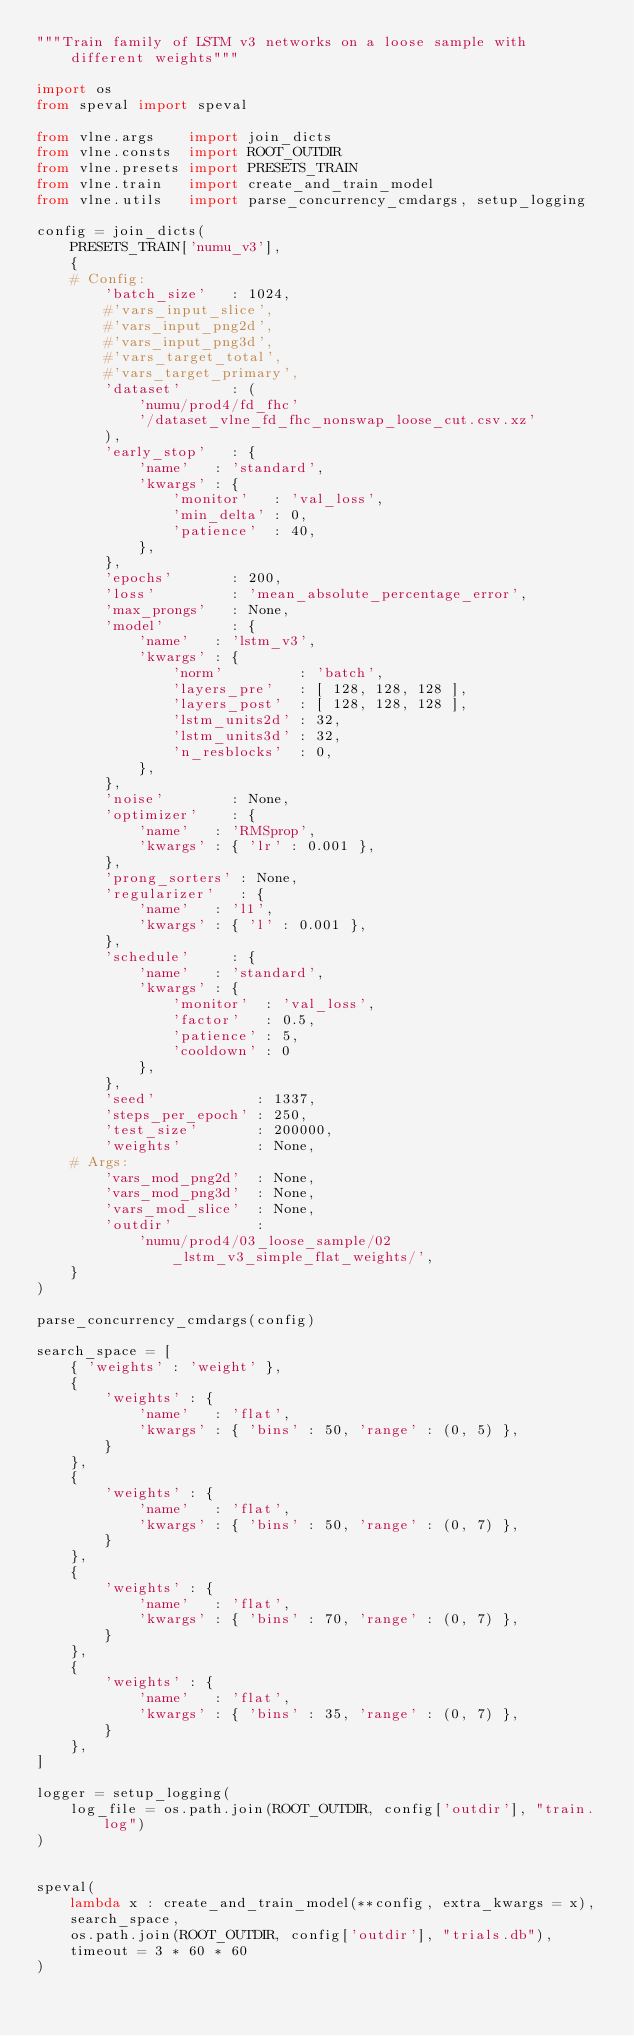Convert code to text. <code><loc_0><loc_0><loc_500><loc_500><_Python_>"""Train family of LSTM v3 networks on a loose sample with different weights"""

import os
from speval import speval

from vlne.args    import join_dicts
from vlne.consts  import ROOT_OUTDIR
from vlne.presets import PRESETS_TRAIN
from vlne.train   import create_and_train_model
from vlne.utils   import parse_concurrency_cmdargs, setup_logging

config = join_dicts(
    PRESETS_TRAIN['numu_v3'],
    {
    # Config:
        'batch_size'   : 1024,
        #'vars_input_slice',
        #'vars_input_png2d',
        #'vars_input_png3d',
        #'vars_target_total',
        #'vars_target_primary',
        'dataset'      : (
            'numu/prod4/fd_fhc'
            '/dataset_vlne_fd_fhc_nonswap_loose_cut.csv.xz'
        ),
        'early_stop'   : {
            'name'   : 'standard',
            'kwargs' : {
                'monitor'   : 'val_loss',
                'min_delta' : 0,
                'patience'  : 40,
            },
        },
        'epochs'       : 200,
        'loss'         : 'mean_absolute_percentage_error',
        'max_prongs'   : None,
        'model'        : {
            'name'   : 'lstm_v3',
            'kwargs' : {
                'norm'         : 'batch',
                'layers_pre'   : [ 128, 128, 128 ],
                'layers_post'  : [ 128, 128, 128 ],
                'lstm_units2d' : 32,
                'lstm_units3d' : 32,
                'n_resblocks'  : 0,
            },
        },
        'noise'        : None,
        'optimizer'    : {
            'name'   : 'RMSprop',
            'kwargs' : { 'lr' : 0.001 },
        },
        'prong_sorters' : None,
        'regularizer'   : {
            'name'   : 'l1',
            'kwargs' : { 'l' : 0.001 },
        },
        'schedule'     : {
            'name'   : 'standard',
            'kwargs' : {
                'monitor'  : 'val_loss',
                'factor'   : 0.5,
                'patience' : 5,
                'cooldown' : 0
            },
        },
        'seed'            : 1337,
        'steps_per_epoch' : 250,
        'test_size'       : 200000,
        'weights'         : None,
    # Args:
        'vars_mod_png2d'  : None,
        'vars_mod_png3d'  : None,
        'vars_mod_slice'  : None,
        'outdir'          :
            'numu/prod4/03_loose_sample/02_lstm_v3_simple_flat_weights/',
    }
)

parse_concurrency_cmdargs(config)

search_space = [
    { 'weights' : 'weight' },
    {
        'weights' : {
            'name'   : 'flat',
            'kwargs' : { 'bins' : 50, 'range' : (0, 5) },
        }
    },
    {
        'weights' : {
            'name'   : 'flat',
            'kwargs' : { 'bins' : 50, 'range' : (0, 7) },
        }
    },
    {
        'weights' : {
            'name'   : 'flat',
            'kwargs' : { 'bins' : 70, 'range' : (0, 7) },
        }
    },
    {
        'weights' : {
            'name'   : 'flat',
            'kwargs' : { 'bins' : 35, 'range' : (0, 7) },
        }
    },
]

logger = setup_logging(
    log_file = os.path.join(ROOT_OUTDIR, config['outdir'], "train.log")
)


speval(
    lambda x : create_and_train_model(**config, extra_kwargs = x),
    search_space,
    os.path.join(ROOT_OUTDIR, config['outdir'], "trials.db"),
    timeout = 3 * 60 * 60
)


</code> 